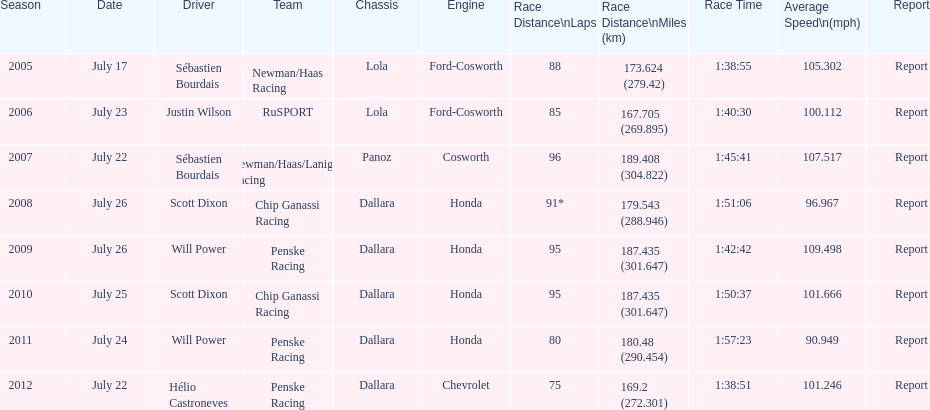What's the overall count of honda engines manufactured? 4. 